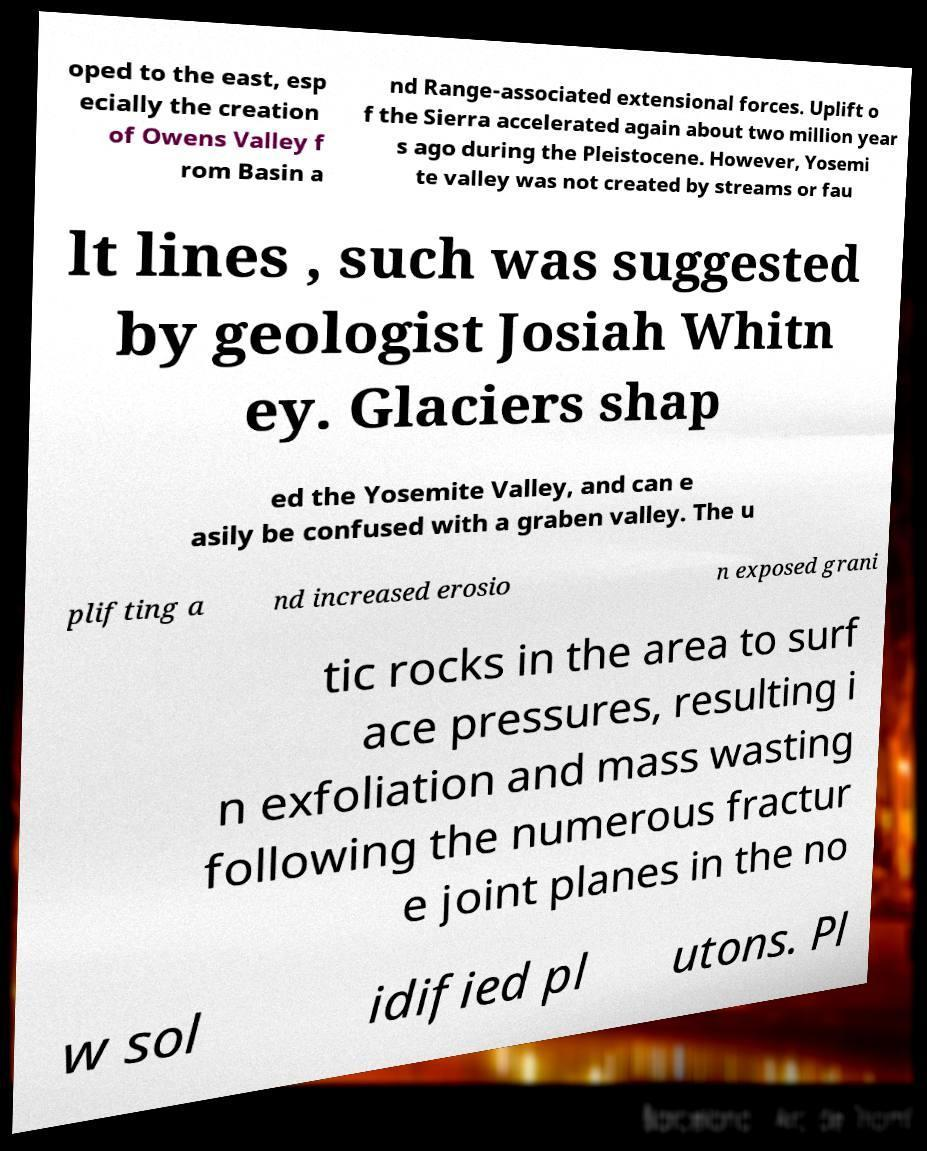Can you read and provide the text displayed in the image?This photo seems to have some interesting text. Can you extract and type it out for me? oped to the east, esp ecially the creation of Owens Valley f rom Basin a nd Range-associated extensional forces. Uplift o f the Sierra accelerated again about two million year s ago during the Pleistocene. However, Yosemi te valley was not created by streams or fau lt lines , such was suggested by geologist Josiah Whitn ey. Glaciers shap ed the Yosemite Valley, and can e asily be confused with a graben valley. The u plifting a nd increased erosio n exposed grani tic rocks in the area to surf ace pressures, resulting i n exfoliation and mass wasting following the numerous fractur e joint planes in the no w sol idified pl utons. Pl 